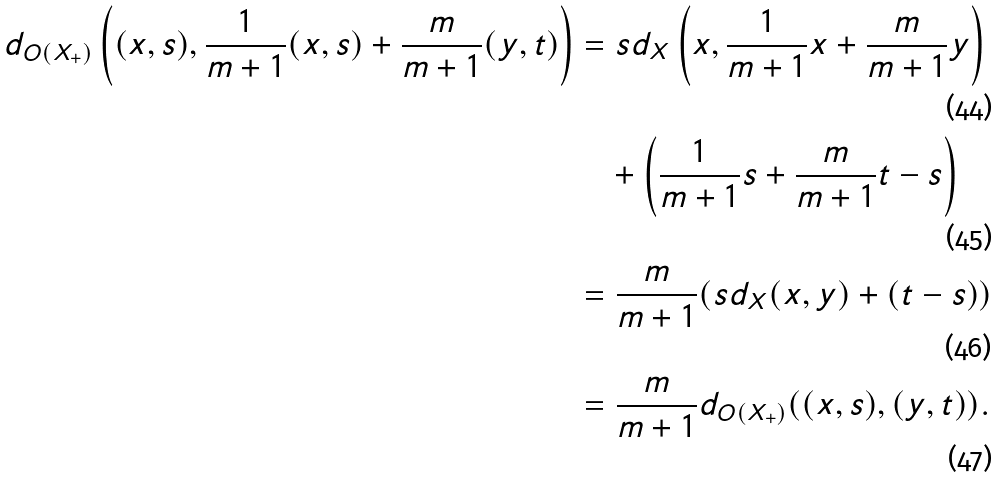Convert formula to latex. <formula><loc_0><loc_0><loc_500><loc_500>d _ { O ( X _ { + } ) } \left ( ( x , s ) , \frac { 1 } { m + 1 } ( x , s ) + \frac { m } { m + 1 } ( y , t ) \right ) & = s d _ { X } \left ( x , \frac { 1 } { m + 1 } x + \frac { m } { m + 1 } y \right ) \\ & \quad + \left ( \frac { 1 } { m + 1 } s + \frac { m } { m + 1 } t - s \right ) \\ & = \frac { m } { m + 1 } ( s d _ { X } ( x , y ) + ( t - s ) ) \\ & = \frac { m } { m + 1 } d _ { O ( X _ { + } ) } ( ( x , s ) , ( y , t ) ) .</formula> 